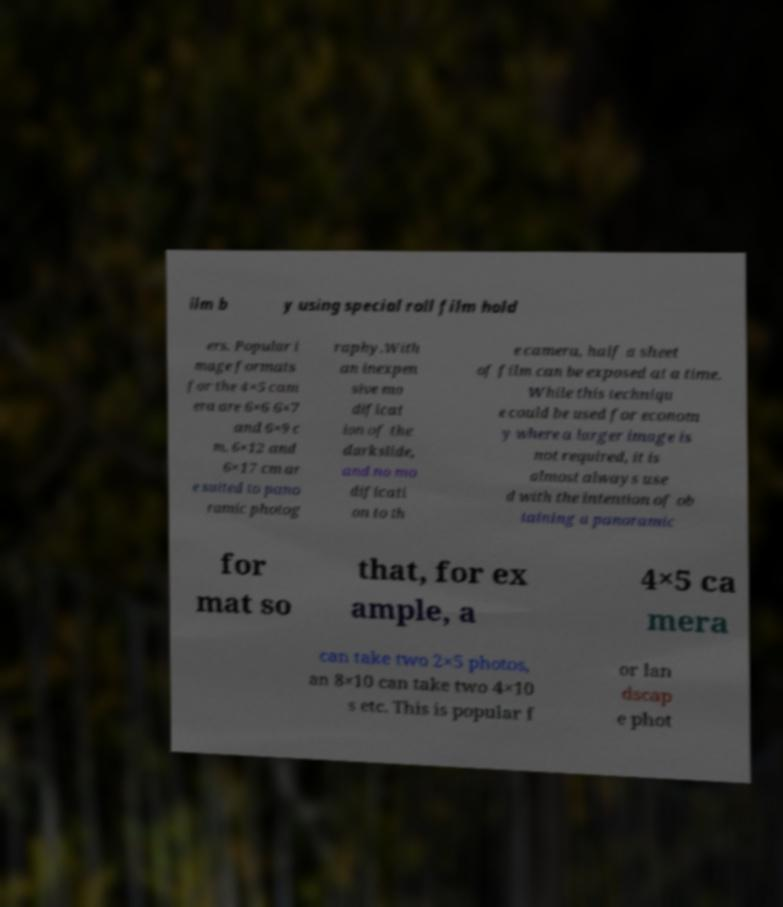Could you assist in decoding the text presented in this image and type it out clearly? ilm b y using special roll film hold ers. Popular i mage formats for the 4×5 cam era are 6×6 6×7 and 6×9 c m. 6×12 and 6×17 cm ar e suited to pano ramic photog raphy.With an inexpen sive mo dificat ion of the darkslide, and no mo dificati on to th e camera, half a sheet of film can be exposed at a time. While this techniqu e could be used for econom y where a larger image is not required, it is almost always use d with the intention of ob taining a panoramic for mat so that, for ex ample, a 4×5 ca mera can take two 2×5 photos, an 8×10 can take two 4×10 s etc. This is popular f or lan dscap e phot 